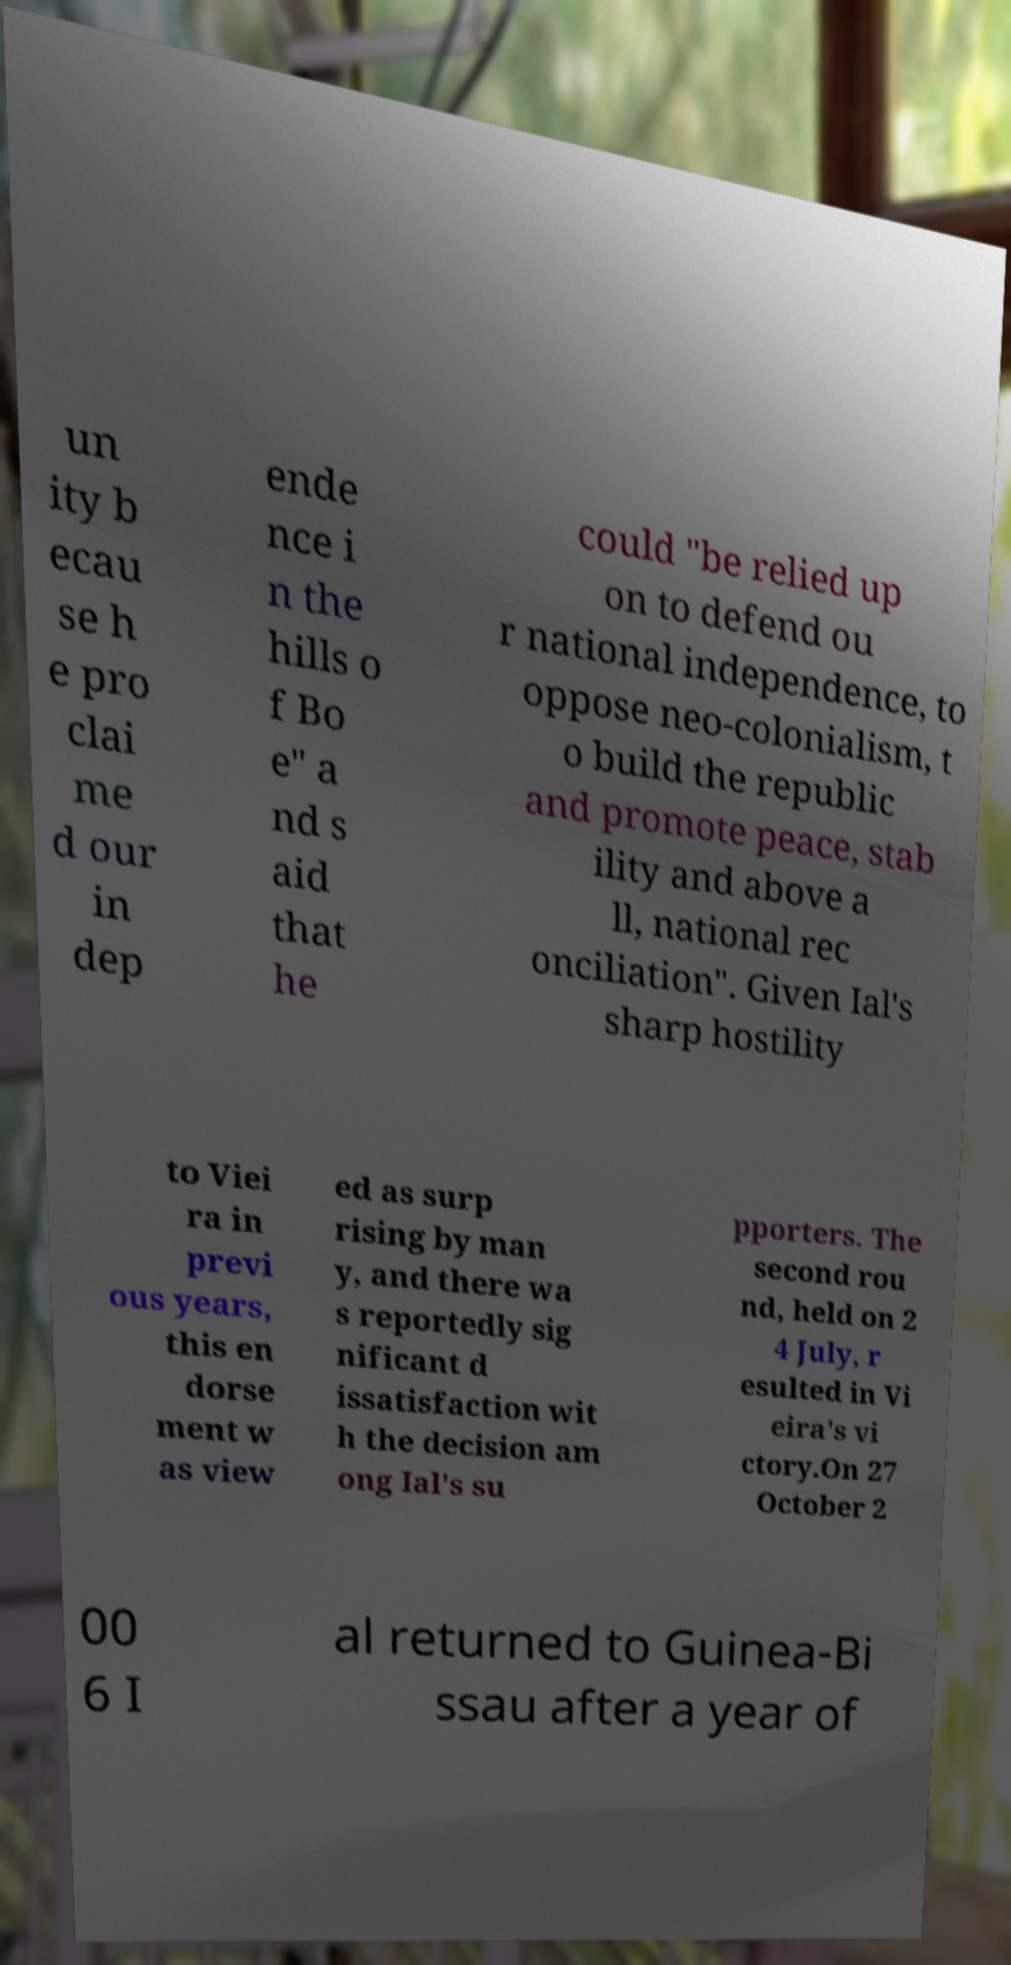Please identify and transcribe the text found in this image. un ity b ecau se h e pro clai me d our in dep ende nce i n the hills o f Bo e" a nd s aid that he could "be relied up on to defend ou r national independence, to oppose neo-colonialism, t o build the republic and promote peace, stab ility and above a ll, national rec onciliation". Given Ial's sharp hostility to Viei ra in previ ous years, this en dorse ment w as view ed as surp rising by man y, and there wa s reportedly sig nificant d issatisfaction wit h the decision am ong Ial's su pporters. The second rou nd, held on 2 4 July, r esulted in Vi eira's vi ctory.On 27 October 2 00 6 I al returned to Guinea-Bi ssau after a year of 